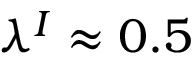Convert formula to latex. <formula><loc_0><loc_0><loc_500><loc_500>\lambda ^ { I } \approx 0 . 5</formula> 